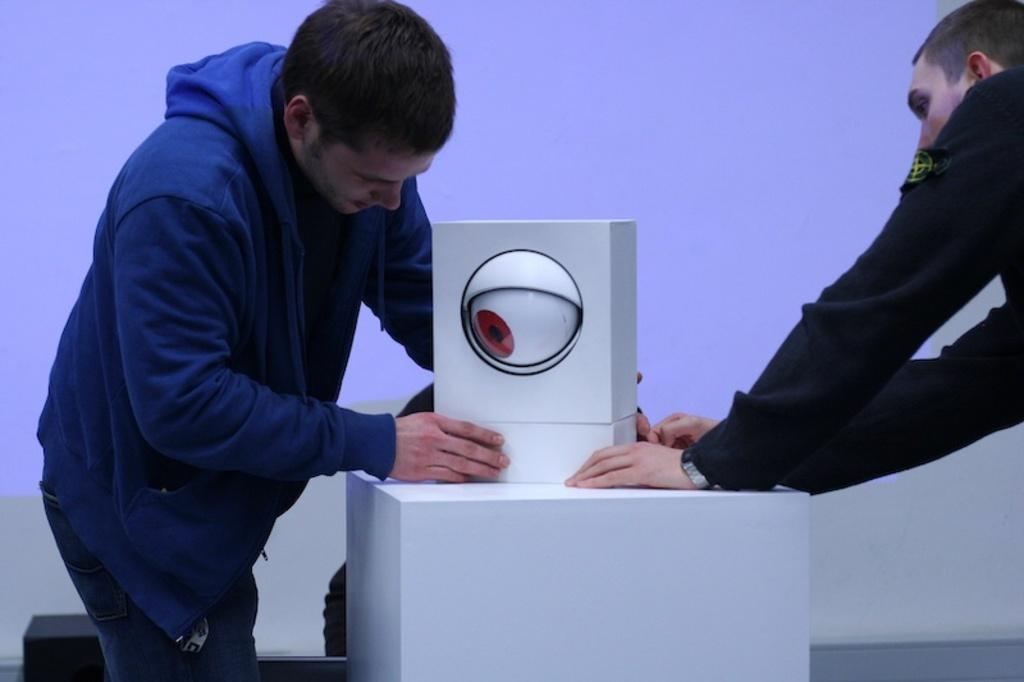How many people are in the image? There are two men in the image. What is on the platform in the image? There is a box on a platform. What is depicted on the box? The box has an eye depicted on it. What can be seen in the background of the image? There is a screen in the background of the image. What day of the week is it in the image? The day of the week is not mentioned or depicted in the image. What type of army is present in the image? There is no army present in the image. 